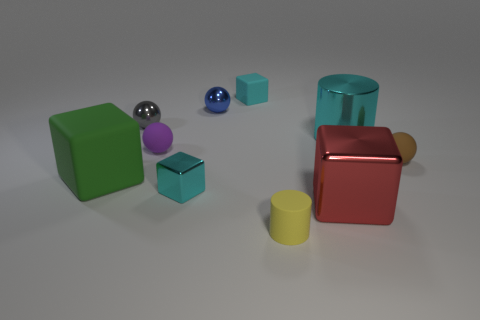Subtract all brown balls. How many balls are left? 3 Subtract all purple spheres. How many spheres are left? 3 Add 8 big blue rubber cylinders. How many big blue rubber cylinders exist? 8 Subtract 1 brown balls. How many objects are left? 9 Subtract all cylinders. How many objects are left? 8 Subtract 1 spheres. How many spheres are left? 3 Subtract all red spheres. Subtract all yellow cubes. How many spheres are left? 4 Subtract all yellow cubes. How many cyan cylinders are left? 1 Subtract all cyan metal cylinders. Subtract all big cyan spheres. How many objects are left? 9 Add 9 red metallic things. How many red metallic things are left? 10 